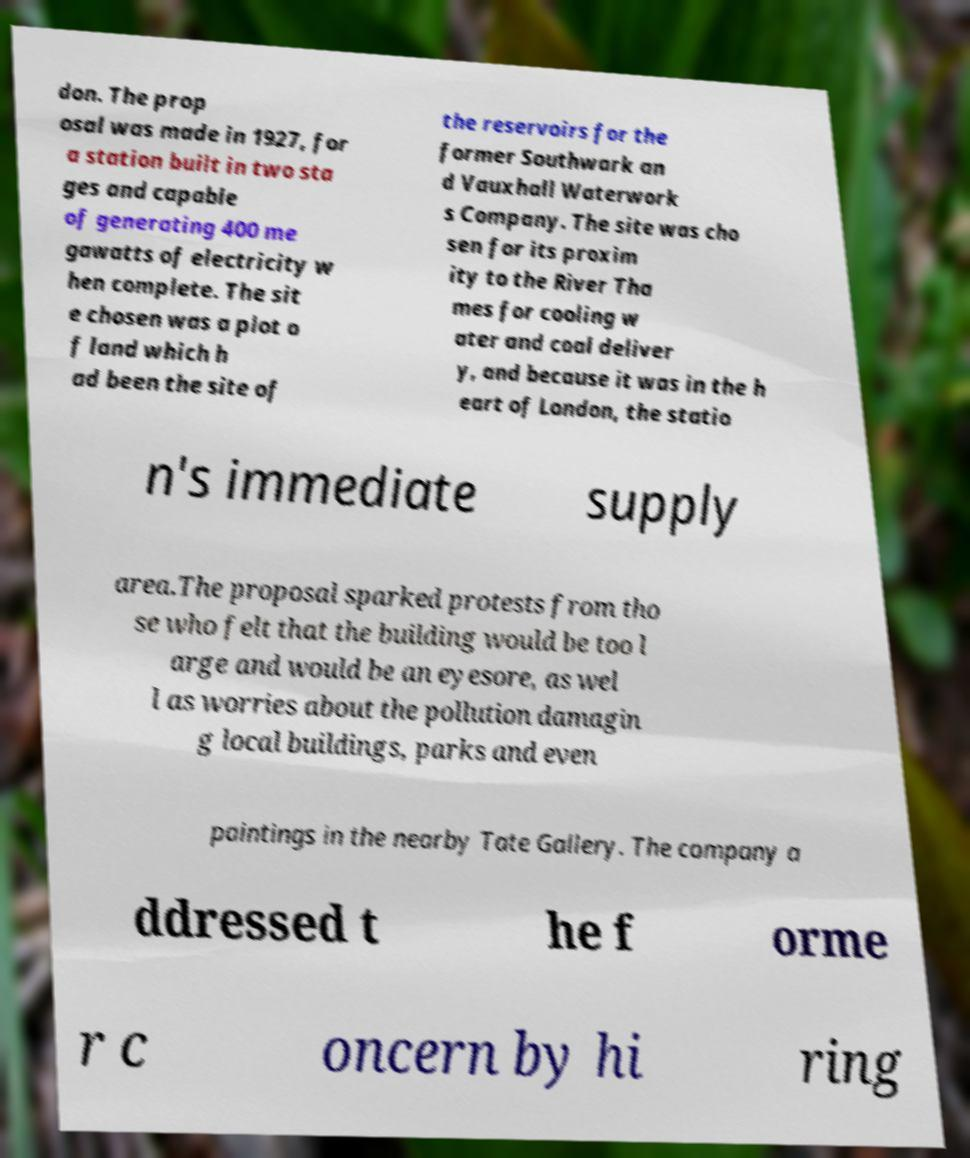There's text embedded in this image that I need extracted. Can you transcribe it verbatim? don. The prop osal was made in 1927, for a station built in two sta ges and capable of generating 400 me gawatts of electricity w hen complete. The sit e chosen was a plot o f land which h ad been the site of the reservoirs for the former Southwark an d Vauxhall Waterwork s Company. The site was cho sen for its proxim ity to the River Tha mes for cooling w ater and coal deliver y, and because it was in the h eart of London, the statio n's immediate supply area.The proposal sparked protests from tho se who felt that the building would be too l arge and would be an eyesore, as wel l as worries about the pollution damagin g local buildings, parks and even paintings in the nearby Tate Gallery. The company a ddressed t he f orme r c oncern by hi ring 